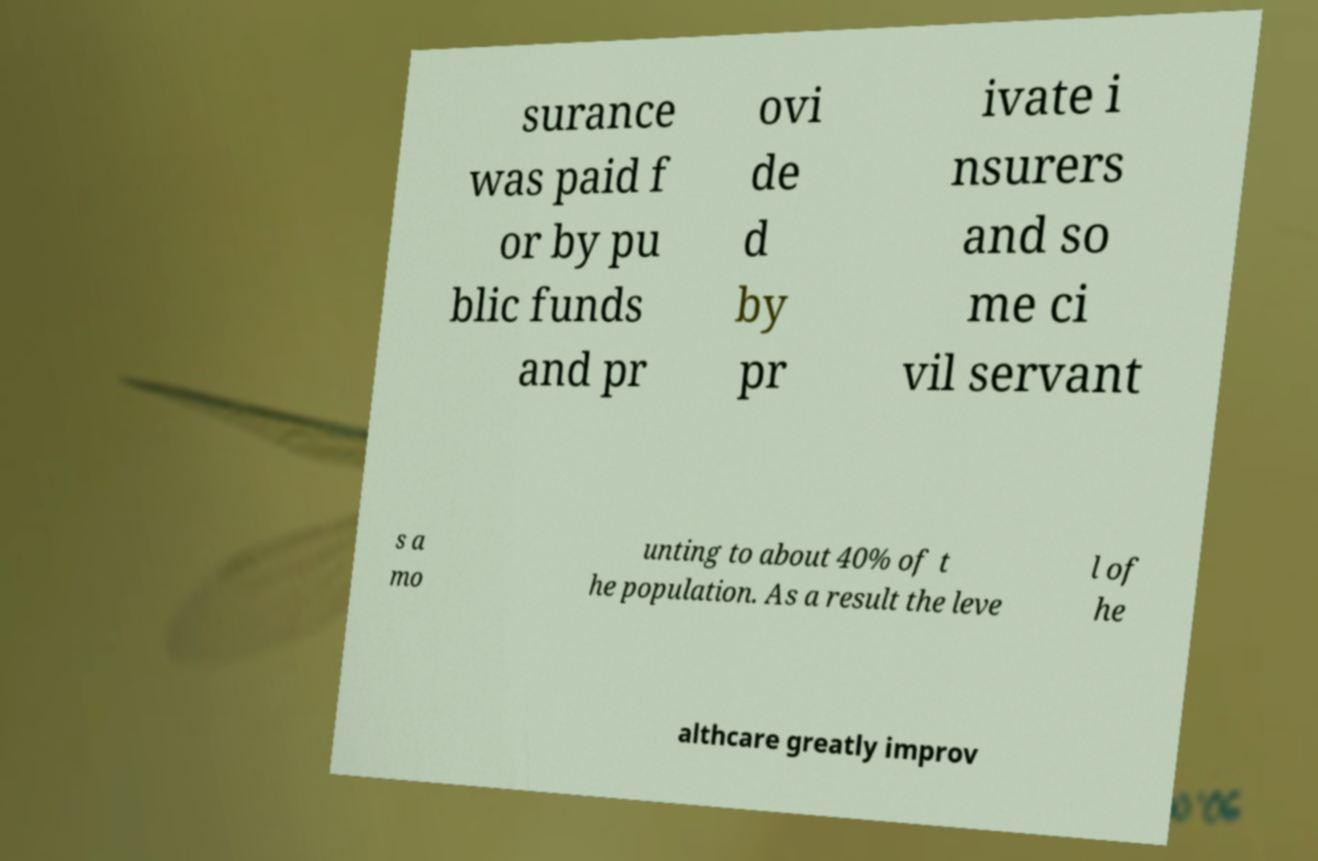What messages or text are displayed in this image? I need them in a readable, typed format. surance was paid f or by pu blic funds and pr ovi de d by pr ivate i nsurers and so me ci vil servant s a mo unting to about 40% of t he population. As a result the leve l of he althcare greatly improv 